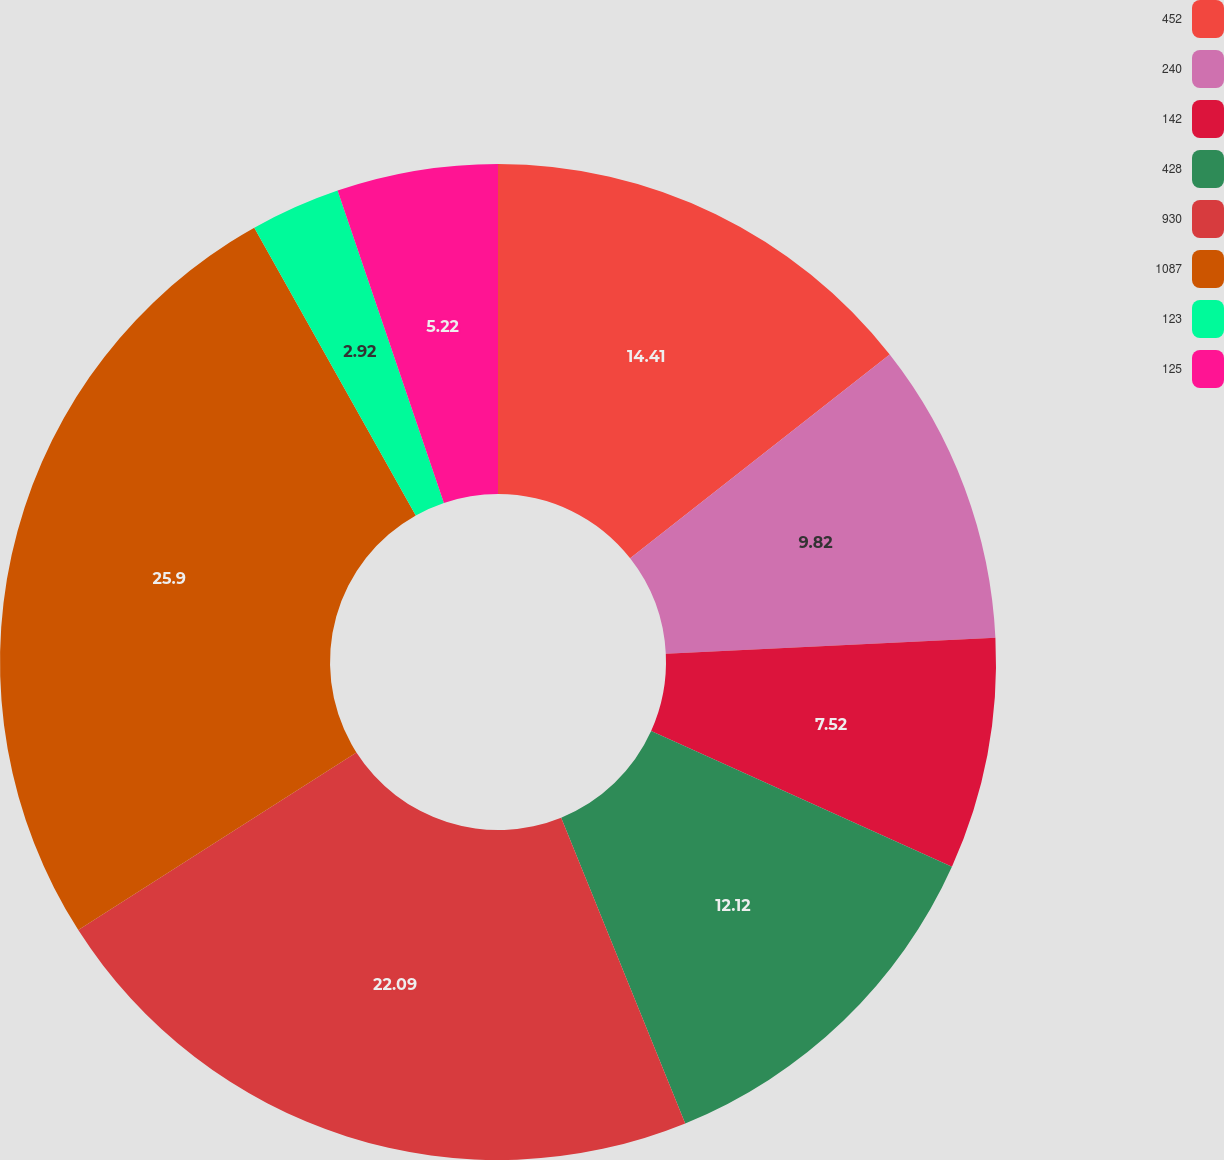Convert chart. <chart><loc_0><loc_0><loc_500><loc_500><pie_chart><fcel>452<fcel>240<fcel>142<fcel>428<fcel>930<fcel>1087<fcel>123<fcel>125<nl><fcel>14.41%<fcel>9.82%<fcel>7.52%<fcel>12.12%<fcel>22.09%<fcel>25.91%<fcel>2.92%<fcel>5.22%<nl></chart> 